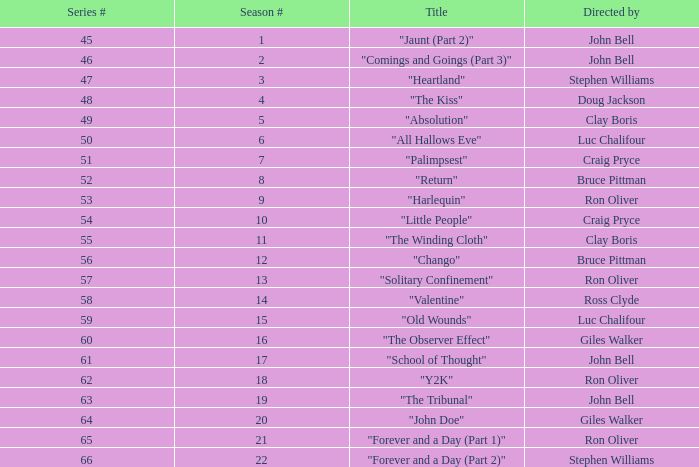Which Season # has a Title of "jaunt (part 2)", and a Series # larger than 45? None. 